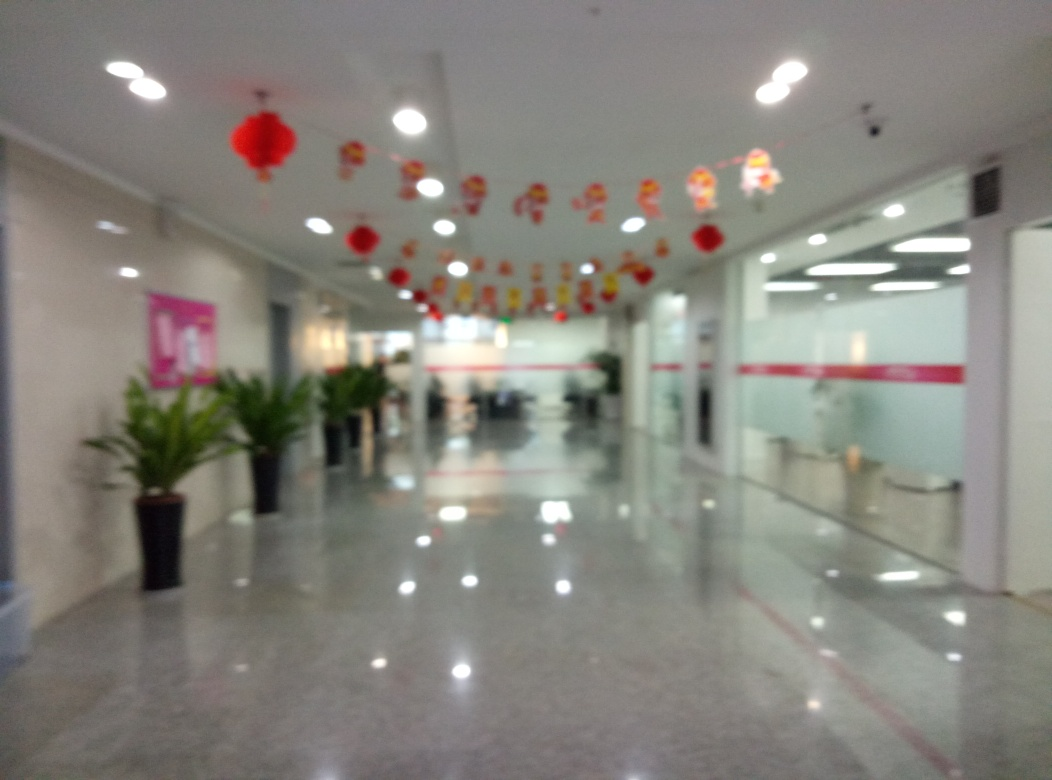Are the lighting conditions adequate in the image? The image appears to show an indoor setting with multiple light sources on the ceiling, providing ample illumination to the space. However, due to the image's blurred quality, it's challenging to accurately assess the effectiveness of the lighting. From what can be discerned, the lighting seems sufficient for the area. 